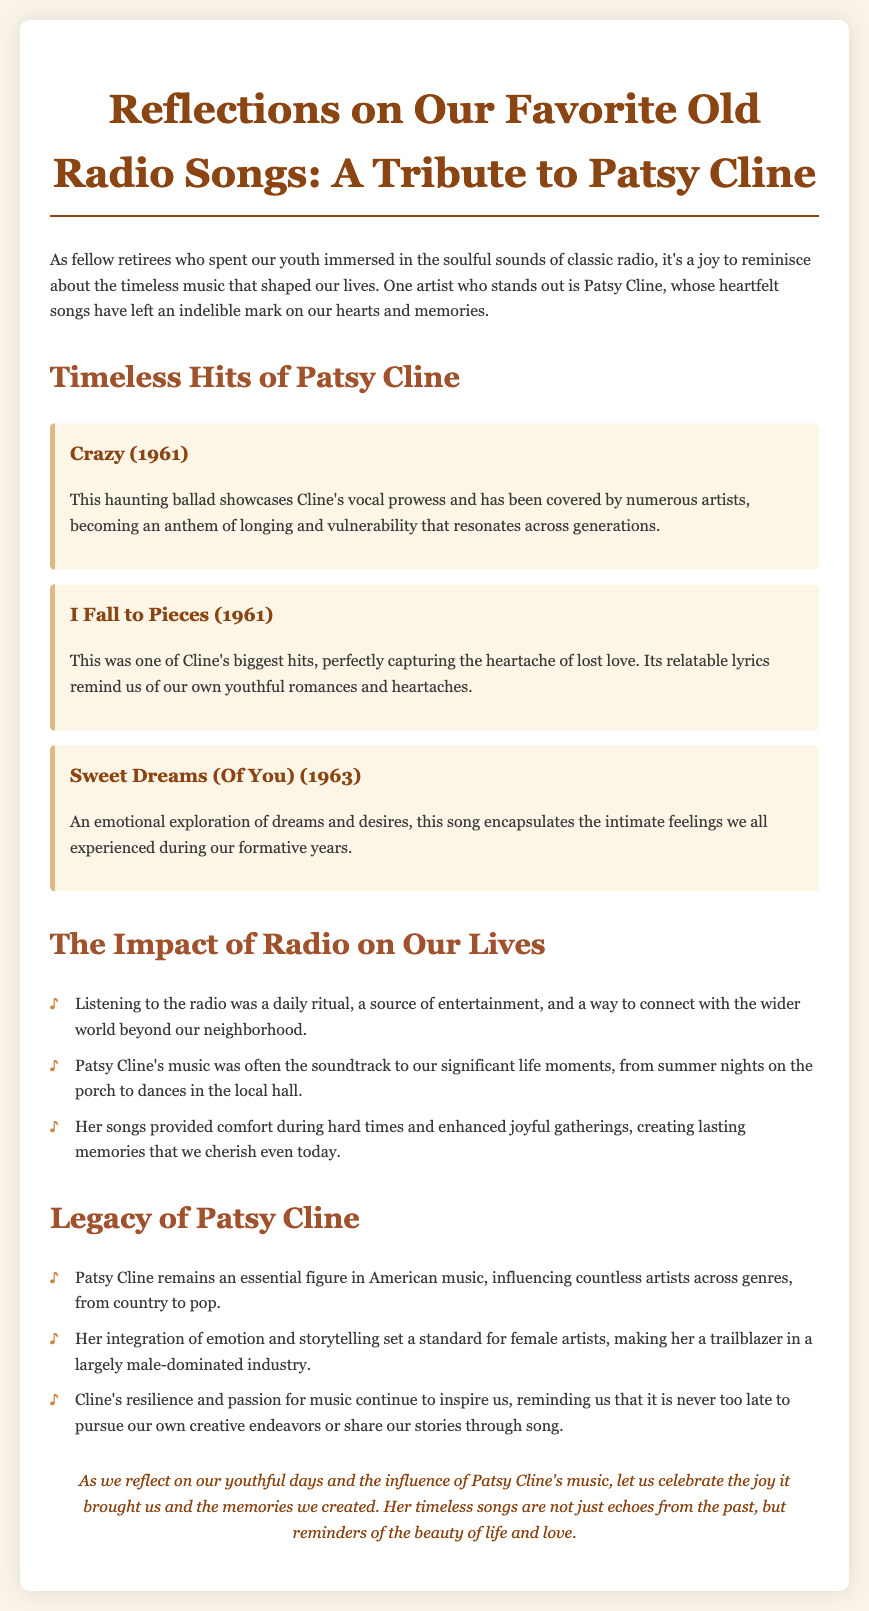What year was "Crazy" released? "Crazy" was released in 1961, as stated in the title information.
Answer: 1961 What is the main theme of "I Fall to Pieces"? The main theme of "I Fall to Pieces" is the heartache of lost love, as described in the document.
Answer: Heartache of lost love Which song explores dreams and desires? The document states that "Sweet Dreams (Of You)" encapsulates the intimate feelings of dreams and desires.
Answer: Sweet Dreams (Of You) What impact did listening to the radio have on our lives? Listening to the radio served as a source of entertainment and a way to connect with the world beyond our neighborhood, as mentioned in the impact section.
Answer: Source of entertainment How did Patsy Cline influence female artists? Patsy Cline set a standard for female artists and was a trailblazer in a largely male-dominated industry, according to the document.
Answer: Trailblazer in a male-dominated industry What is a key characteristic of Patsy Cline's songs? Patsy Cline's songs are characterized by emotion and storytelling, as highlighted in the legacy section.
Answer: Emotion and storytelling What are we reminded of by Cline's songs? The conclusion states that Cline's songs remind us of the beauty of life and love.
Answer: Beauty of life and love Which song is described as an anthem of longing? The song "Crazy" is noted as an anthem of longing and vulnerability in the document.
Answer: Crazy 